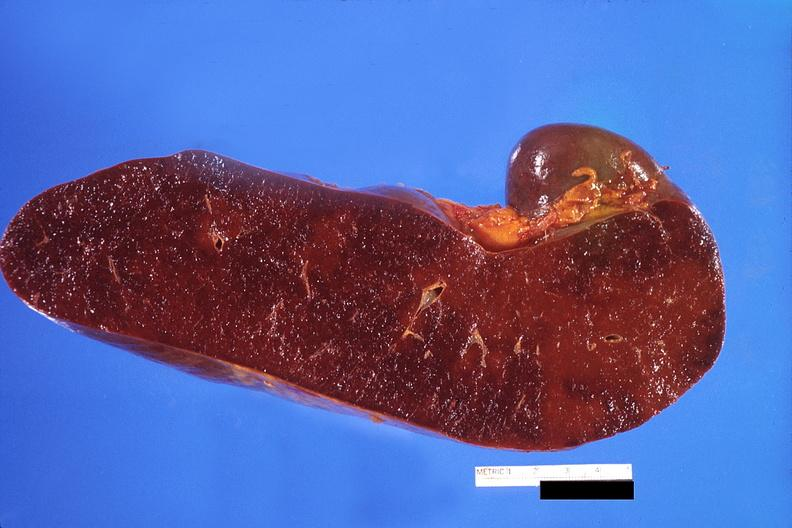does intramural one lesion show spleen, congestion?
Answer the question using a single word or phrase. No 